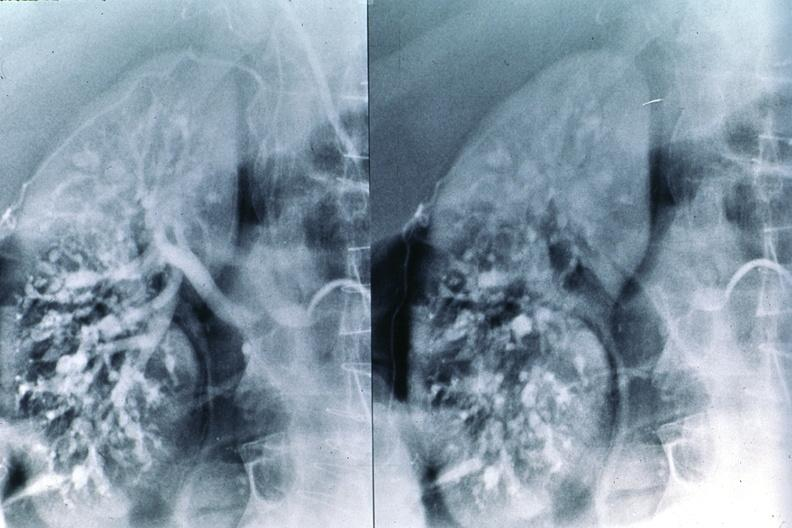does cytomegaly show polyarteritis nodosa, kidney arteriogram?
Answer the question using a single word or phrase. No 